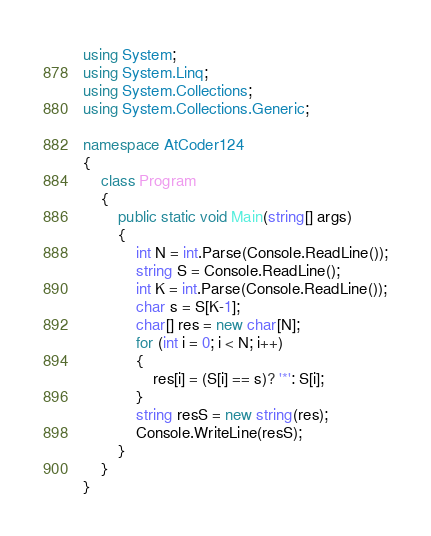<code> <loc_0><loc_0><loc_500><loc_500><_C#_>using System;
using System.Linq;
using System.Collections;
using System.Collections.Generic;

namespace AtCoder124
{
    class Program
    {
        public static void Main(string[] args)
        {
            int N = int.Parse(Console.ReadLine());
            string S = Console.ReadLine();
            int K = int.Parse(Console.ReadLine());
            char s = S[K-1];
            char[] res = new char[N];
            for (int i = 0; i < N; i++)
            {
                res[i] = (S[i] == s)? '*': S[i];
            }
            string resS = new string(res);
            Console.WriteLine(resS);
        }
    }
}</code> 